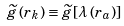<formula> <loc_0><loc_0><loc_500><loc_500>\widetilde { g } \left ( r _ { k } \right ) \equiv \widetilde { g } \left [ \lambda \left ( r _ { a } \right ) \right ]</formula> 